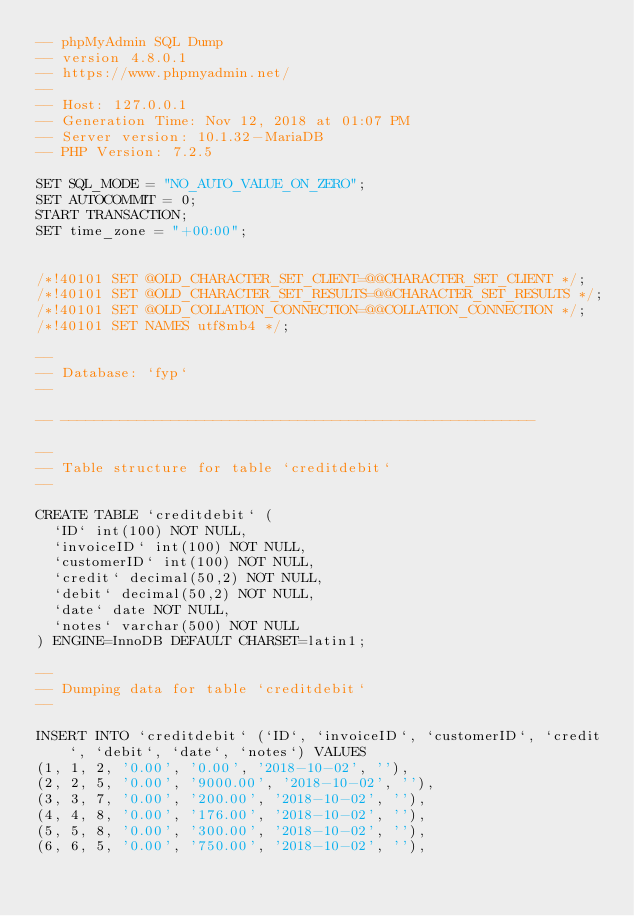<code> <loc_0><loc_0><loc_500><loc_500><_SQL_>-- phpMyAdmin SQL Dump
-- version 4.8.0.1
-- https://www.phpmyadmin.net/
--
-- Host: 127.0.0.1
-- Generation Time: Nov 12, 2018 at 01:07 PM
-- Server version: 10.1.32-MariaDB
-- PHP Version: 7.2.5

SET SQL_MODE = "NO_AUTO_VALUE_ON_ZERO";
SET AUTOCOMMIT = 0;
START TRANSACTION;
SET time_zone = "+00:00";


/*!40101 SET @OLD_CHARACTER_SET_CLIENT=@@CHARACTER_SET_CLIENT */;
/*!40101 SET @OLD_CHARACTER_SET_RESULTS=@@CHARACTER_SET_RESULTS */;
/*!40101 SET @OLD_COLLATION_CONNECTION=@@COLLATION_CONNECTION */;
/*!40101 SET NAMES utf8mb4 */;

--
-- Database: `fyp`
--

-- --------------------------------------------------------

--
-- Table structure for table `creditdebit`
--

CREATE TABLE `creditdebit` (
  `ID` int(100) NOT NULL,
  `invoiceID` int(100) NOT NULL,
  `customerID` int(100) NOT NULL,
  `credit` decimal(50,2) NOT NULL,
  `debit` decimal(50,2) NOT NULL,
  `date` date NOT NULL,
  `notes` varchar(500) NOT NULL
) ENGINE=InnoDB DEFAULT CHARSET=latin1;

--
-- Dumping data for table `creditdebit`
--

INSERT INTO `creditdebit` (`ID`, `invoiceID`, `customerID`, `credit`, `debit`, `date`, `notes`) VALUES
(1, 1, 2, '0.00', '0.00', '2018-10-02', ''),
(2, 2, 5, '0.00', '9000.00', '2018-10-02', ''),
(3, 3, 7, '0.00', '200.00', '2018-10-02', ''),
(4, 4, 8, '0.00', '176.00', '2018-10-02', ''),
(5, 5, 8, '0.00', '300.00', '2018-10-02', ''),
(6, 6, 5, '0.00', '750.00', '2018-10-02', ''),</code> 